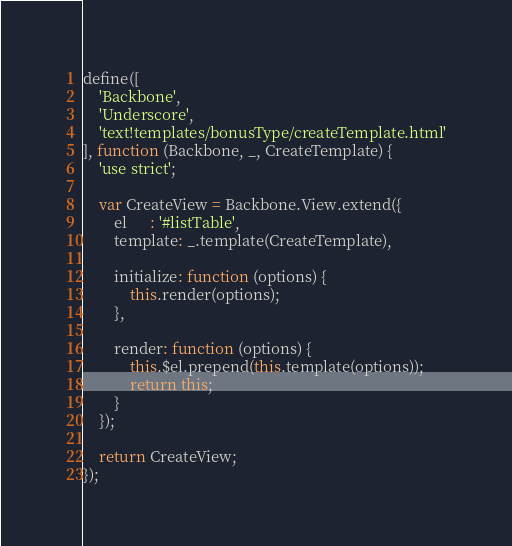Convert code to text. <code><loc_0><loc_0><loc_500><loc_500><_JavaScript_>define([
    'Backbone',
    'Underscore',
    'text!templates/bonusType/createTemplate.html'
], function (Backbone, _, CreateTemplate) {
    'use strict';

    var CreateView = Backbone.View.extend({
        el      : '#listTable',
        template: _.template(CreateTemplate),

        initialize: function (options) {
            this.render(options);
        },

        render: function (options) {
            this.$el.prepend(this.template(options));
            return this;
        }
    });

    return CreateView;
});
</code> 